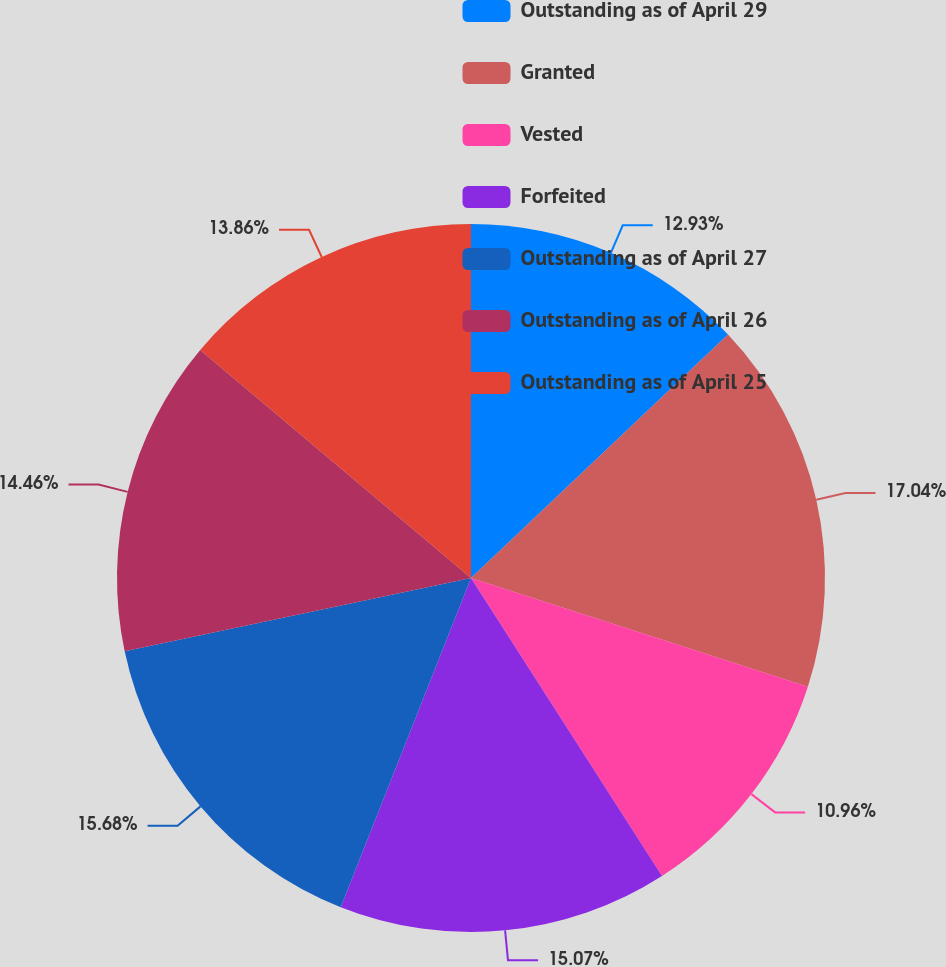Convert chart to OTSL. <chart><loc_0><loc_0><loc_500><loc_500><pie_chart><fcel>Outstanding as of April 29<fcel>Granted<fcel>Vested<fcel>Forfeited<fcel>Outstanding as of April 27<fcel>Outstanding as of April 26<fcel>Outstanding as of April 25<nl><fcel>12.93%<fcel>17.04%<fcel>10.96%<fcel>15.07%<fcel>15.68%<fcel>14.46%<fcel>13.86%<nl></chart> 